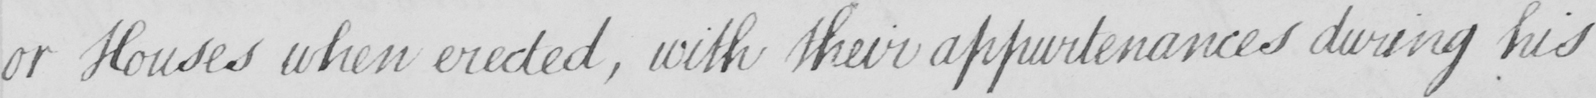What text is written in this handwritten line? or Houses when erected , with their appurtenances during his 